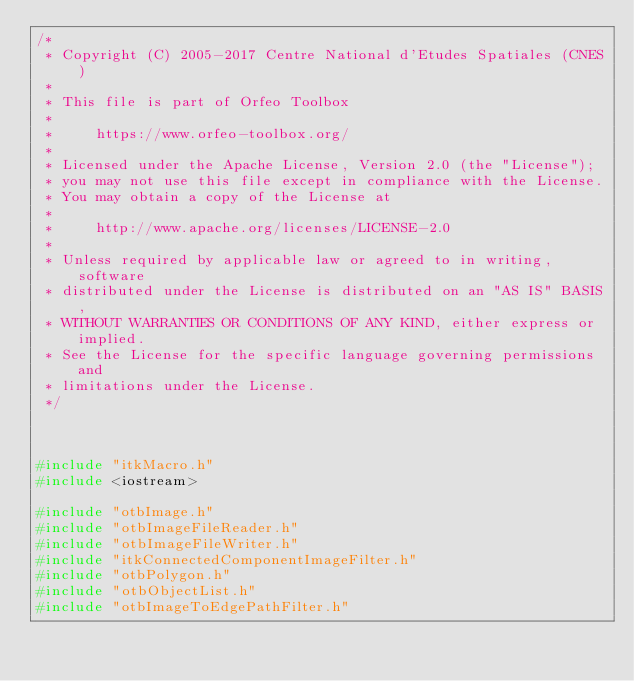Convert code to text. <code><loc_0><loc_0><loc_500><loc_500><_C++_>/*
 * Copyright (C) 2005-2017 Centre National d'Etudes Spatiales (CNES)
 *
 * This file is part of Orfeo Toolbox
 *
 *     https://www.orfeo-toolbox.org/
 *
 * Licensed under the Apache License, Version 2.0 (the "License");
 * you may not use this file except in compliance with the License.
 * You may obtain a copy of the License at
 *
 *     http://www.apache.org/licenses/LICENSE-2.0
 *
 * Unless required by applicable law or agreed to in writing, software
 * distributed under the License is distributed on an "AS IS" BASIS,
 * WITHOUT WARRANTIES OR CONDITIONS OF ANY KIND, either express or implied.
 * See the License for the specific language governing permissions and
 * limitations under the License.
 */



#include "itkMacro.h"
#include <iostream>

#include "otbImage.h"
#include "otbImageFileReader.h"
#include "otbImageFileWriter.h"
#include "itkConnectedComponentImageFilter.h"
#include "otbPolygon.h"
#include "otbObjectList.h"
#include "otbImageToEdgePathFilter.h"</code> 